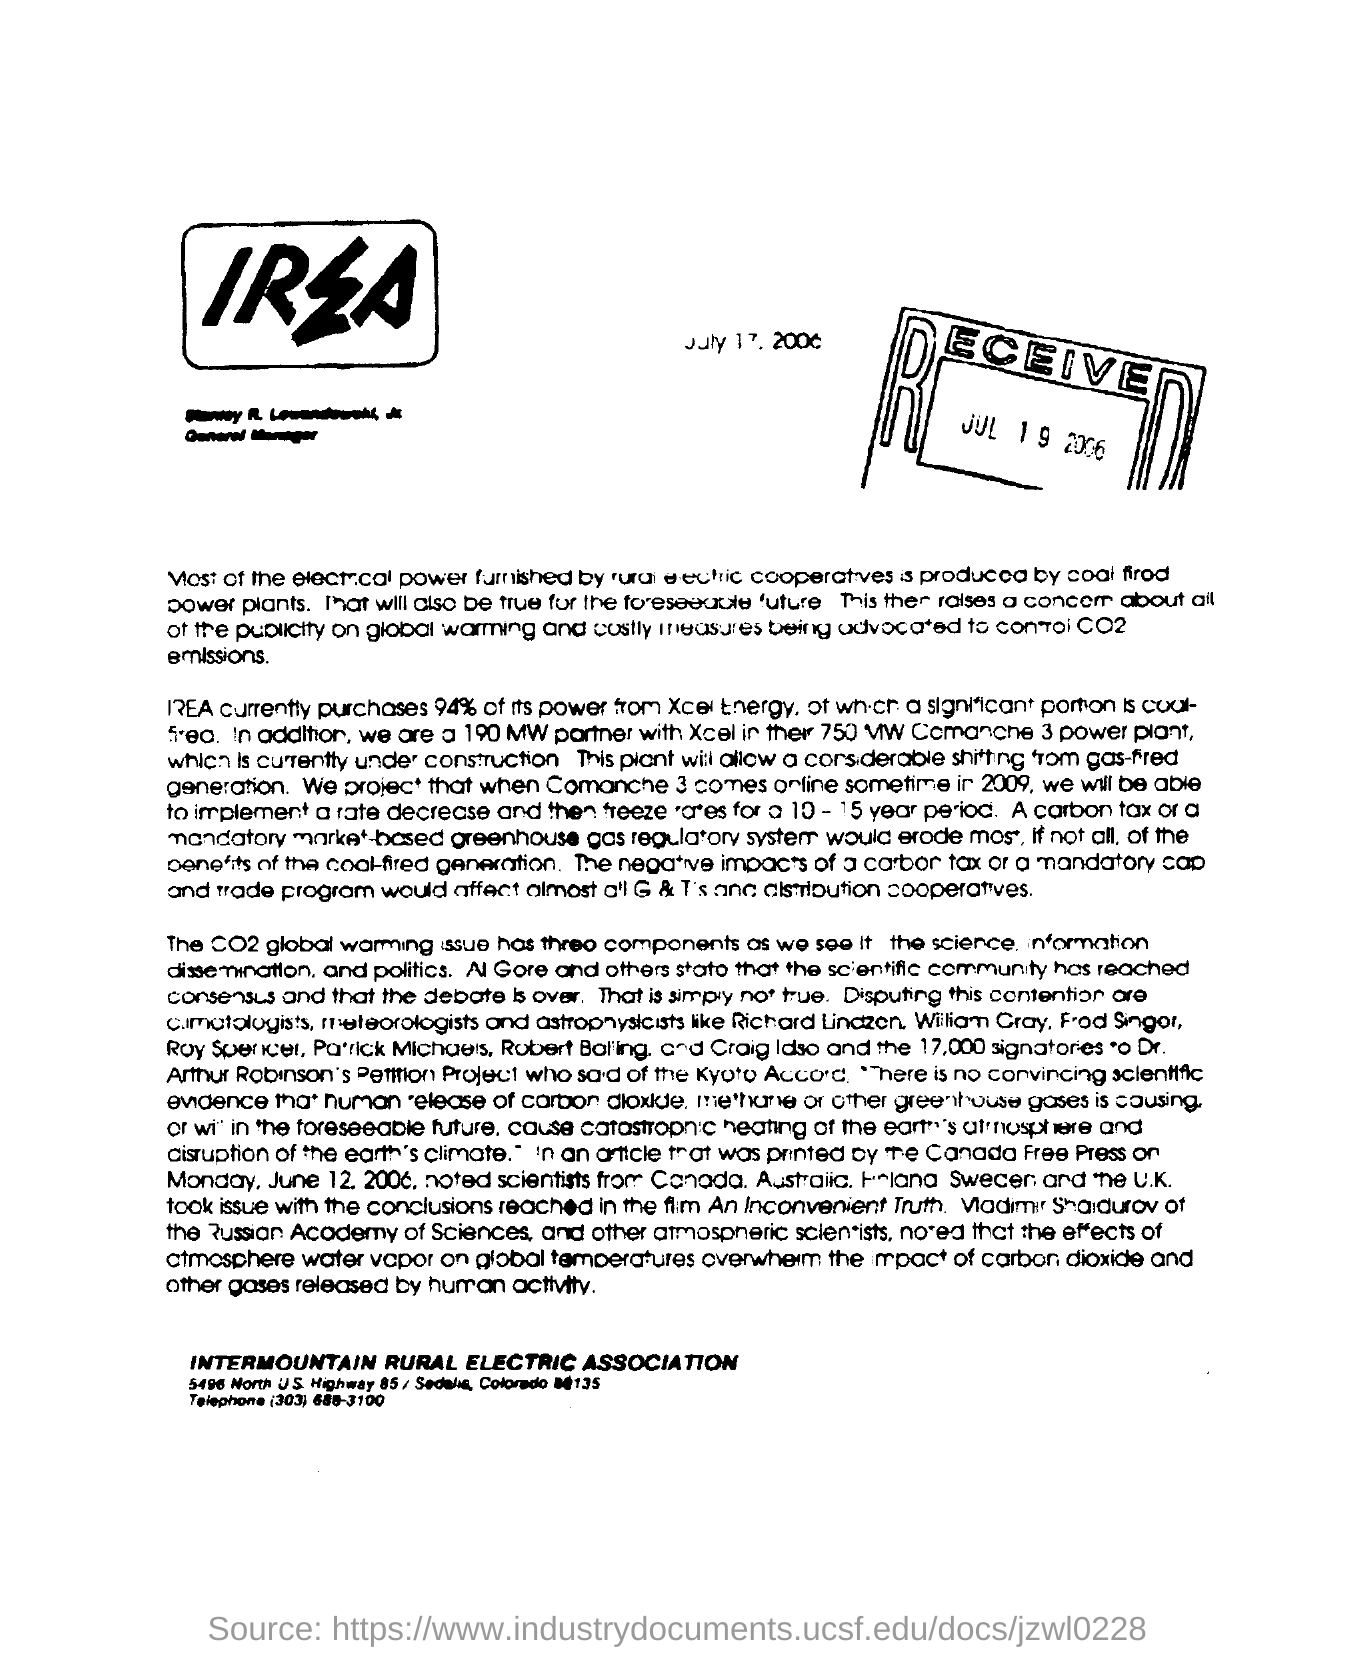Mention a couple of crucial points in this snapshot. The Received date mentioned in the document is JUL 19 2006. 